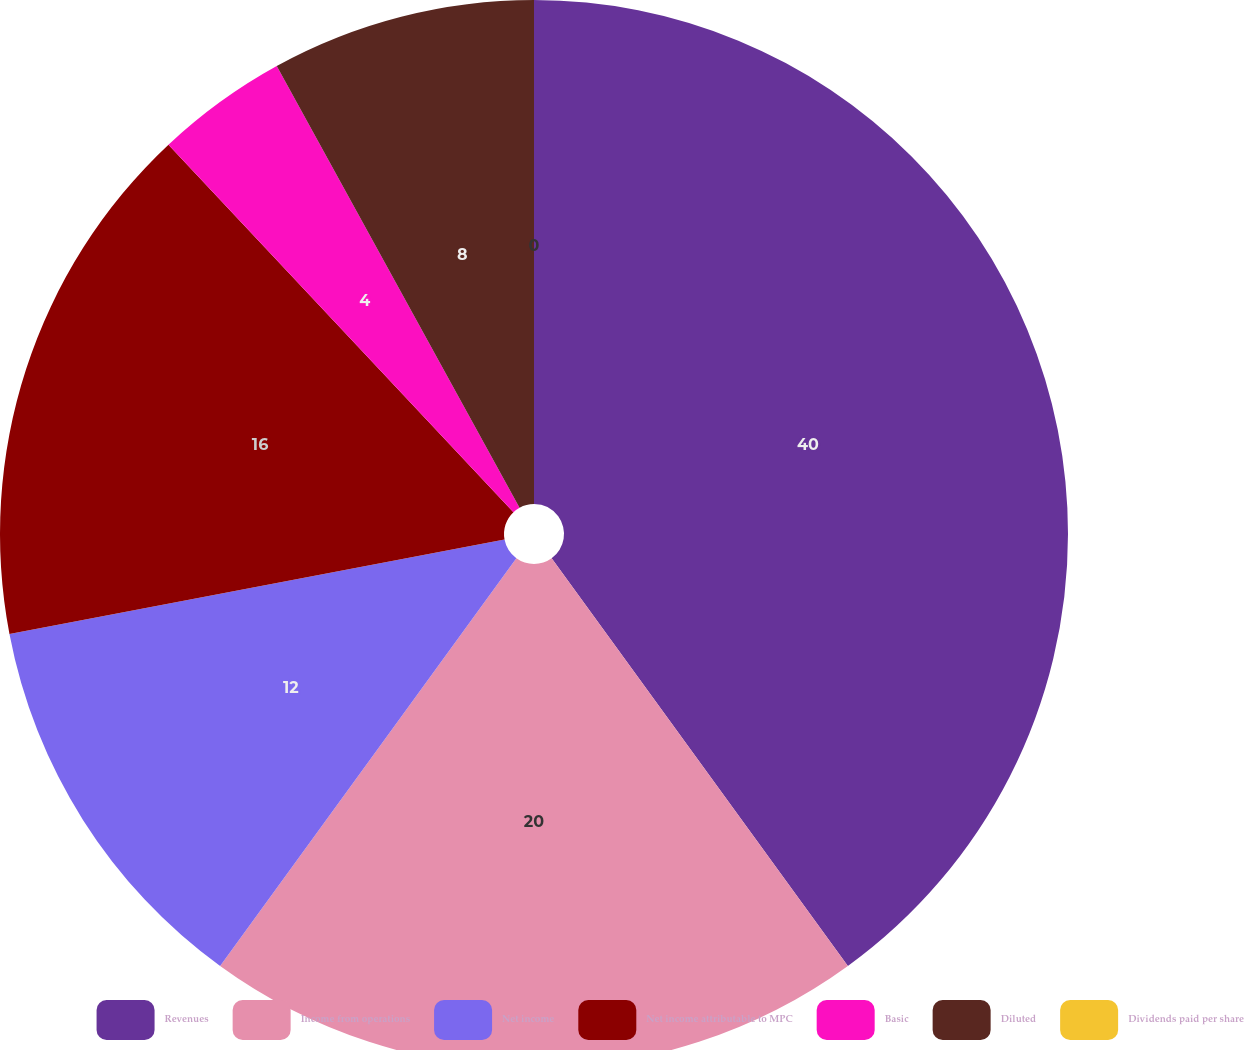Convert chart to OTSL. <chart><loc_0><loc_0><loc_500><loc_500><pie_chart><fcel>Revenues<fcel>Income from operations<fcel>Net income<fcel>Net income attributable to MPC<fcel>Basic<fcel>Diluted<fcel>Dividends paid per share<nl><fcel>40.0%<fcel>20.0%<fcel>12.0%<fcel>16.0%<fcel>4.0%<fcel>8.0%<fcel>0.0%<nl></chart> 